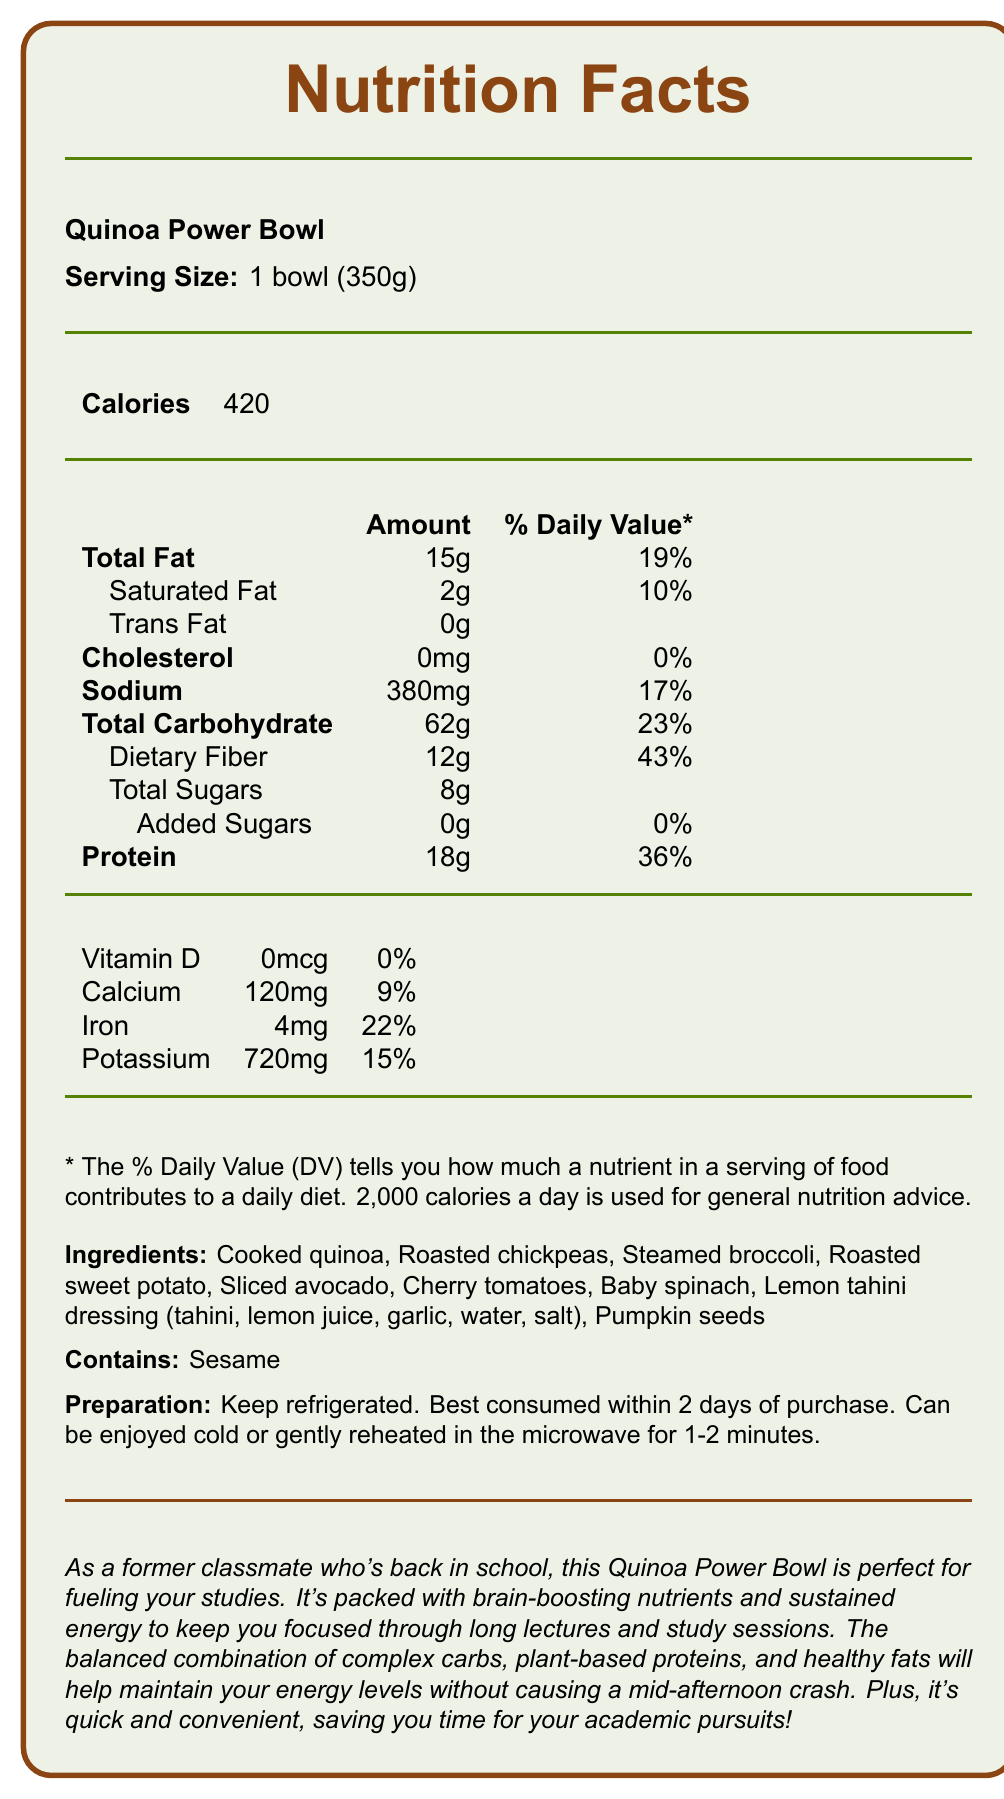what is the product name? The product name is explicitly stated at the beginning of the document: "Quinoa Power Bowl".
Answer: Quinoa Power Bowl what is the serving size? The serving size is mentioned right after the product name and is "1 bowl (350g)".
Answer: 1 bowl (350g) how much total fat does the Quinoa Power Bowl contain per serving? The amount of total fat is listed in the nutrition facts section as 15g.
Answer: 15g what percentage of the daily value of protein is provided by one serving of the Quinoa Power Bowl? The percentage of daily value for protein is specified in the nutrition facts as 36%.
Answer: 36% name three ingredients in the Quinoa Power Bowl. The ingredients are listed in the document, and three of them are Cooked quinoa, Roasted chickpeas, and Steamed broccoli.
Answer: Cooked quinoa, Roasted chickpeas, Steamed broccoli what allergens are present in this meal? The document mentions under the "Contains:" section that the meal contains sesame.
Answer: Sesame What is the daily value percentage of dietary fiber per serving? A. 23% B. 19% C. 43% D. 36% The daily value percentage for dietary fiber per serving is 43%, as indicated in the nutrition facts.
Answer: C. 43% which of these micronutrients is NOT listed in the nutrition facts? A. Vitamin D B. Vitamin C C. Calcium D. Iron Vitamin C is not mentioned in the micronutrient section of the nutrition facts, whereas Vitamin D, Calcium, and Iron are listed.
Answer: B. Vitamin C Does the Quinoa Power Bowl contain any trans fat? The nutrition facts state that the trans fat content is 0g, meaning that it does not contain any trans fat.
Answer: No Summarize the main idea of this document. This document provides comprehensive information about the Quinoa Power Bowl, highlighting its nutritional content, ingredients, preparation methods, and benefits, particularly for individuals seeking a balanced vegetarian meal.
Answer: The Quinoa Power Bowl is a balanced vegetarian lunch option that provides a detailed nutritional breakdown. It is high in dietary fiber and protein, contains healthy fats, and is rich in various vitamins and minerals. The bowl can be consumed cold or reheated and includes ingredients like quinoa, chickpeas, and avocado, making it ideal for sustained energy throughout the day. Is the Quinoa Power Bowl gluten-free? The document does not explicitly mention whether the Quinoa Power Bowl is gluten-free. Therefore, this cannot be determined from the provided details.
Answer: Not enough information How many calories are in one serving of the Quinoa Power Bowl? According to the document, one serving of the Quinoa Power Bowl contains 420 calories.
Answer: 420 What percentage of the daily value of sodium does the Quinoa Power Bowl provide? The percentage of daily value for sodium is given as 17% in the nutrition facts section.
Answer: 17% How many grams of added sugars are there in the Quinoa Power Bowl? The nutrition facts state that there are 0g of added sugars in the Quinoa Power Bowl.
Answer: 0g For how long is the Quinoa Power Bowl best consumed after purchase? The preparation instructions indicate that the Quinoa Power Bowl is best consumed within 2 days of purchase.
Answer: Within 2 days What statement is made specifically to address the needs of students? This message, found towards the end of the document, specifically addresses students by emphasizing the meal's benefits for sustained energy and focus.
Answer: "As a former classmate who's back in school, this Quinoa Power Bowl is perfect for fueling your studies. It's packed with brain-boosting nutrients and sustained energy to keep you focused through long lectures and study sessions." 